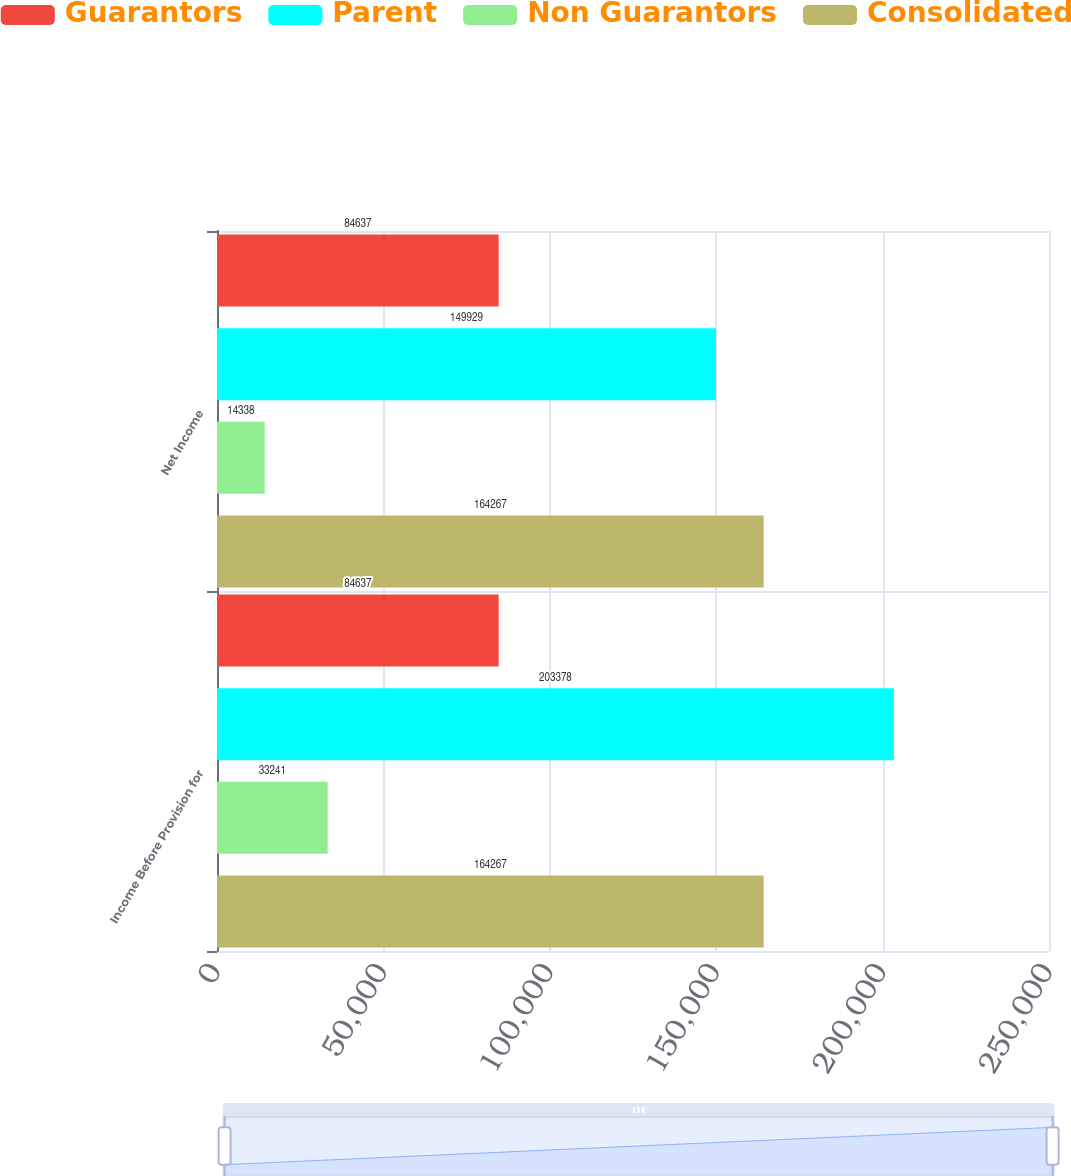Convert chart. <chart><loc_0><loc_0><loc_500><loc_500><stacked_bar_chart><ecel><fcel>Income Before Provision for<fcel>Net Income<nl><fcel>Guarantors<fcel>84637<fcel>84637<nl><fcel>Parent<fcel>203378<fcel>149929<nl><fcel>Non Guarantors<fcel>33241<fcel>14338<nl><fcel>Consolidated<fcel>164267<fcel>164267<nl></chart> 